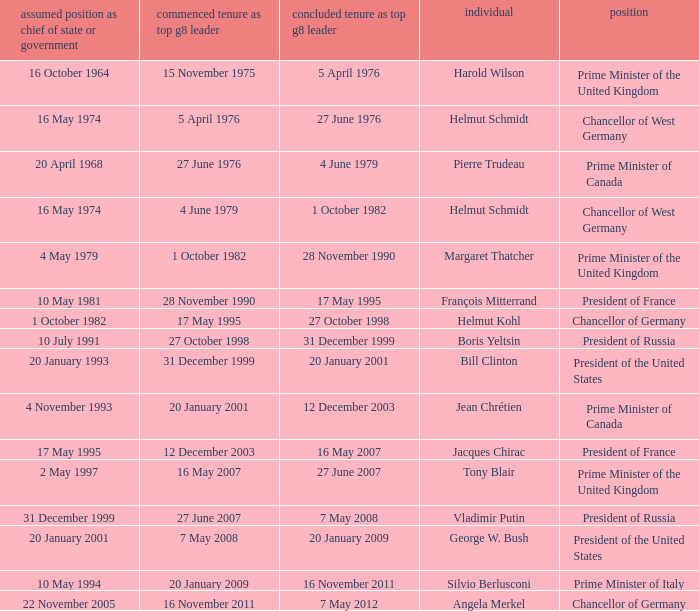When did the Prime Minister of Italy take office? 10 May 1994. 